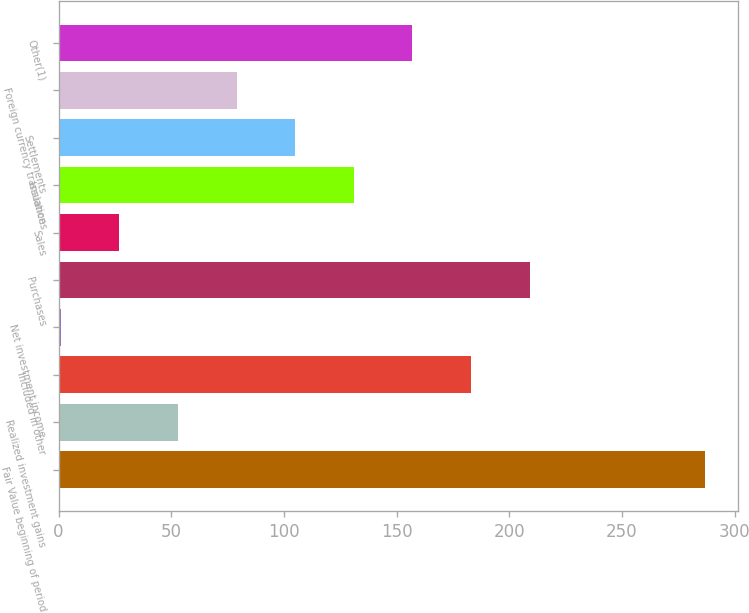Convert chart. <chart><loc_0><loc_0><loc_500><loc_500><bar_chart><fcel>Fair Value beginning of period<fcel>Realized investment gains<fcel>Included in other<fcel>Net investment income<fcel>Purchases<fcel>Sales<fcel>Issuances<fcel>Settlements<fcel>Foreign currency translation<fcel>Other(1)<nl><fcel>287<fcel>53<fcel>183<fcel>1<fcel>209<fcel>27<fcel>131<fcel>105<fcel>79<fcel>157<nl></chart> 